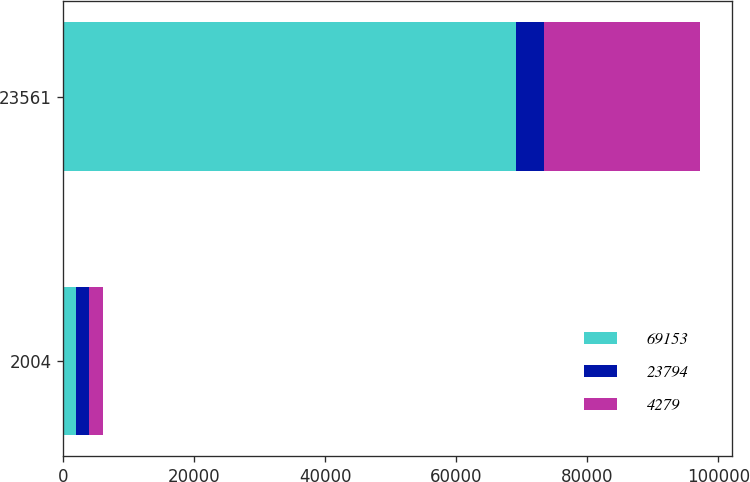Convert chart. <chart><loc_0><loc_0><loc_500><loc_500><stacked_bar_chart><ecel><fcel>2004<fcel>23561<nl><fcel>69153<fcel>2003<fcel>69153<nl><fcel>23794<fcel>2002<fcel>4279<nl><fcel>4279<fcel>2001<fcel>23794<nl></chart> 